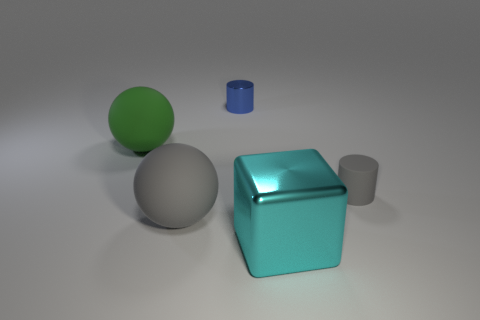Can you describe the lighting in the scene? The lighting in the scene appears to be soft and diffuse, likely coming from an overhead source. The way the light evenly illuminates the objects and casts gentle shadows suggests the presence of ambient lighting which minimizes harsh shadows and highlights. 